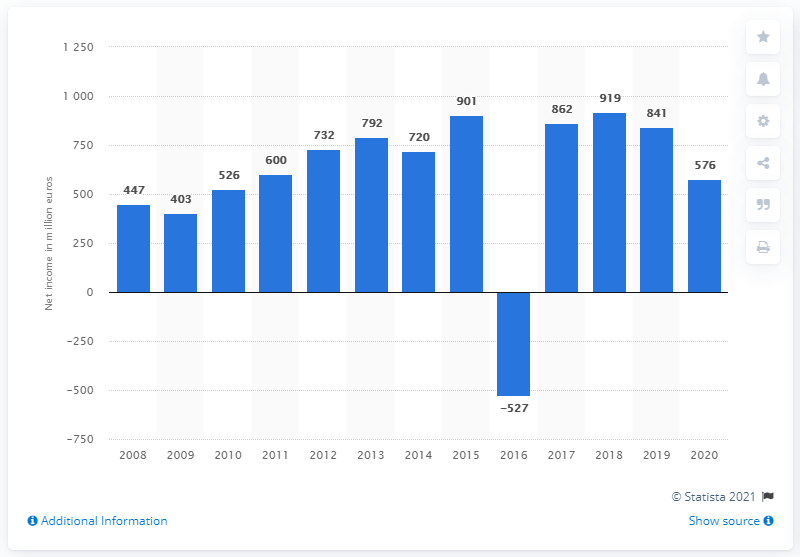Specify some key components in this picture. Publicis Groupe's net income in 2020 was 576 million. Publicis Groupe generated a net income of 841 million Euros in the previous year. 